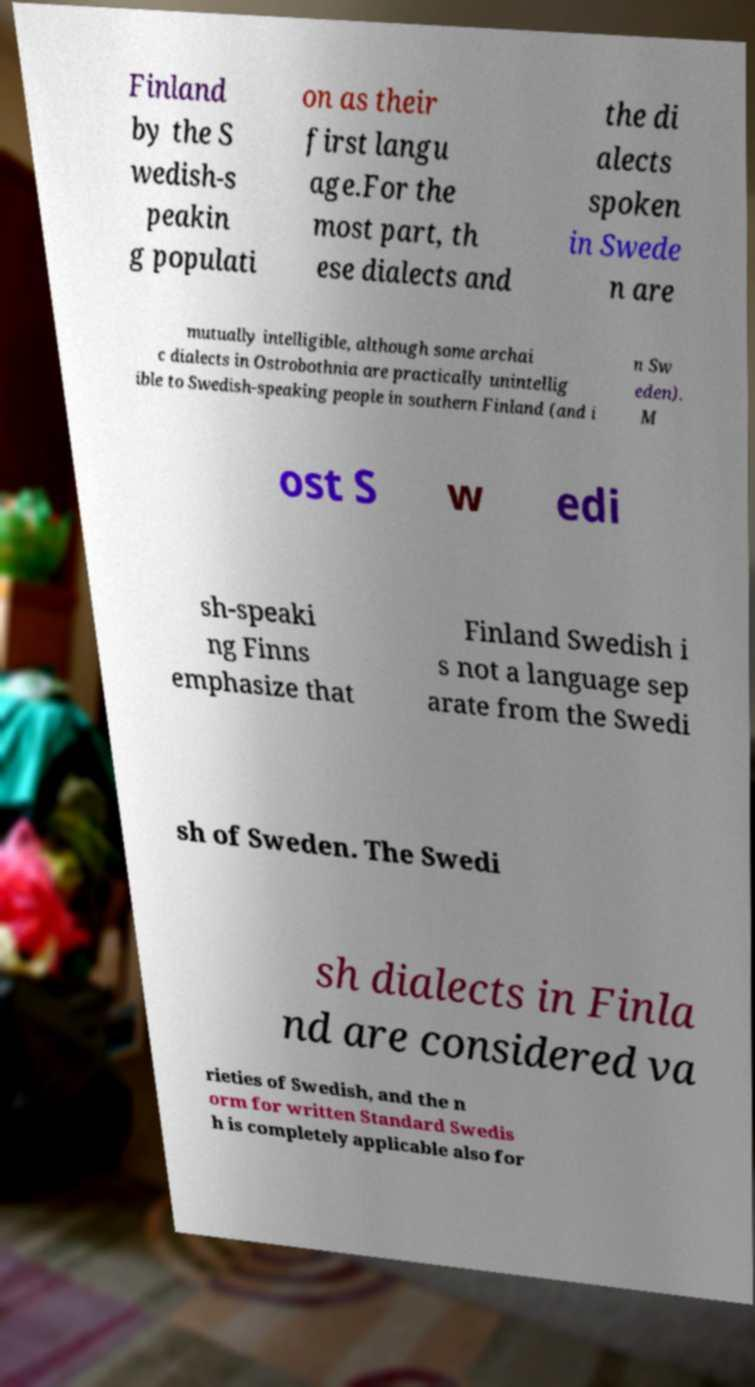What messages or text are displayed in this image? I need them in a readable, typed format. Finland by the S wedish-s peakin g populati on as their first langu age.For the most part, th ese dialects and the di alects spoken in Swede n are mutually intelligible, although some archai c dialects in Ostrobothnia are practically unintellig ible to Swedish-speaking people in southern Finland (and i n Sw eden). M ost S w edi sh-speaki ng Finns emphasize that Finland Swedish i s not a language sep arate from the Swedi sh of Sweden. The Swedi sh dialects in Finla nd are considered va rieties of Swedish, and the n orm for written Standard Swedis h is completely applicable also for 